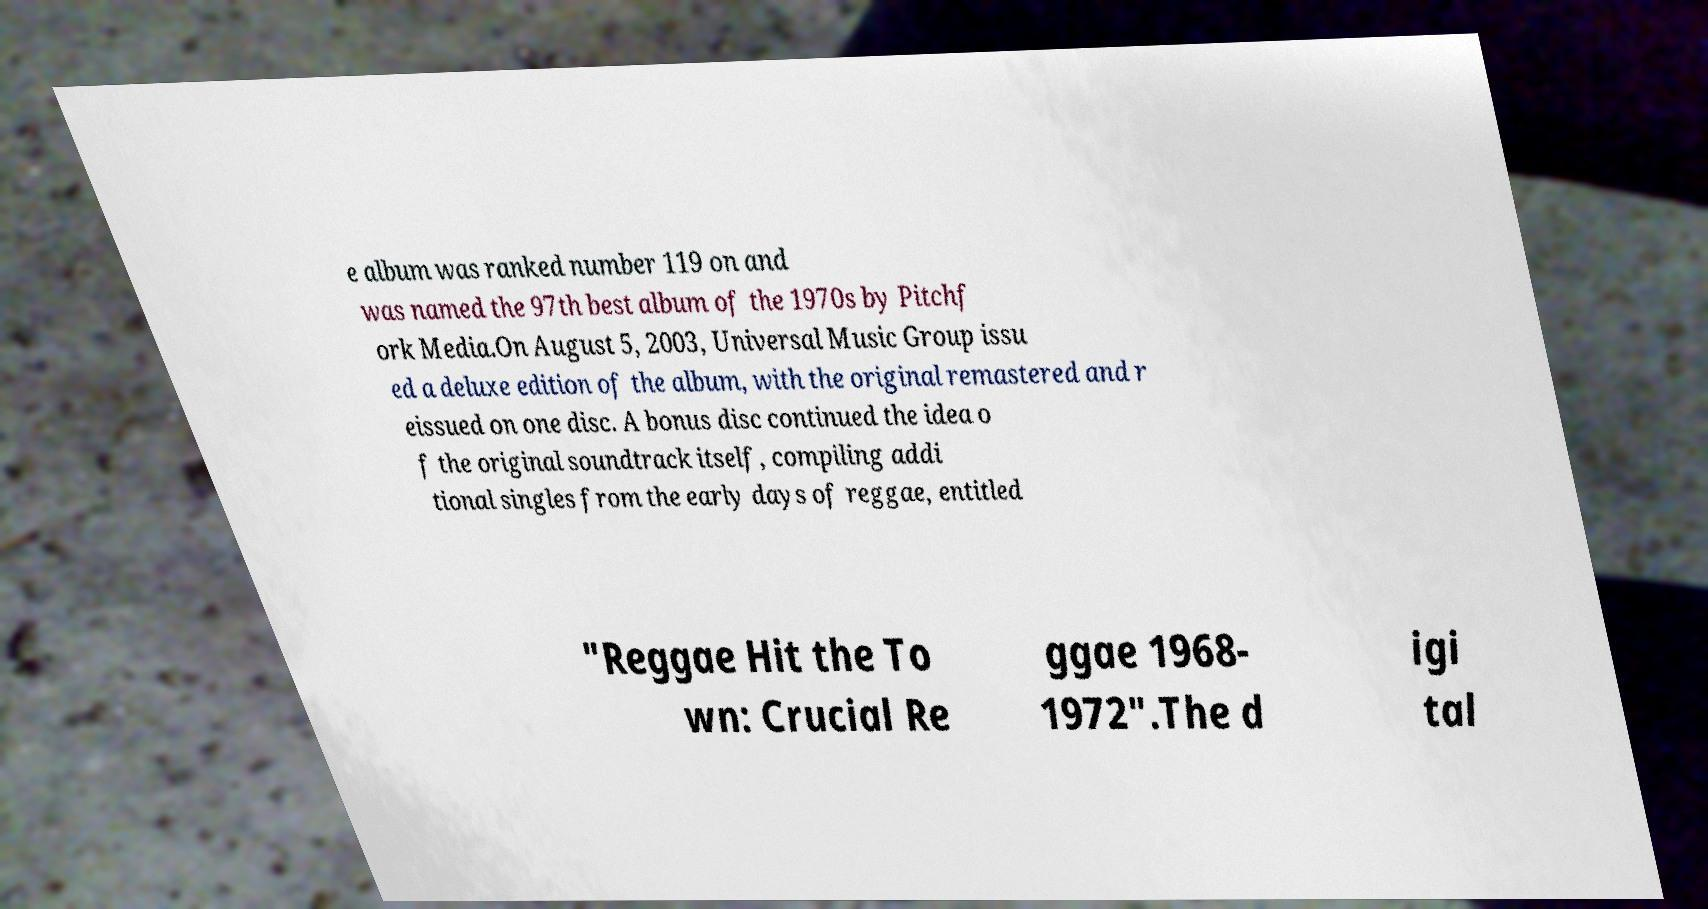Please identify and transcribe the text found in this image. e album was ranked number 119 on and was named the 97th best album of the 1970s by Pitchf ork Media.On August 5, 2003, Universal Music Group issu ed a deluxe edition of the album, with the original remastered and r eissued on one disc. A bonus disc continued the idea o f the original soundtrack itself, compiling addi tional singles from the early days of reggae, entitled "Reggae Hit the To wn: Crucial Re ggae 1968- 1972".The d igi tal 